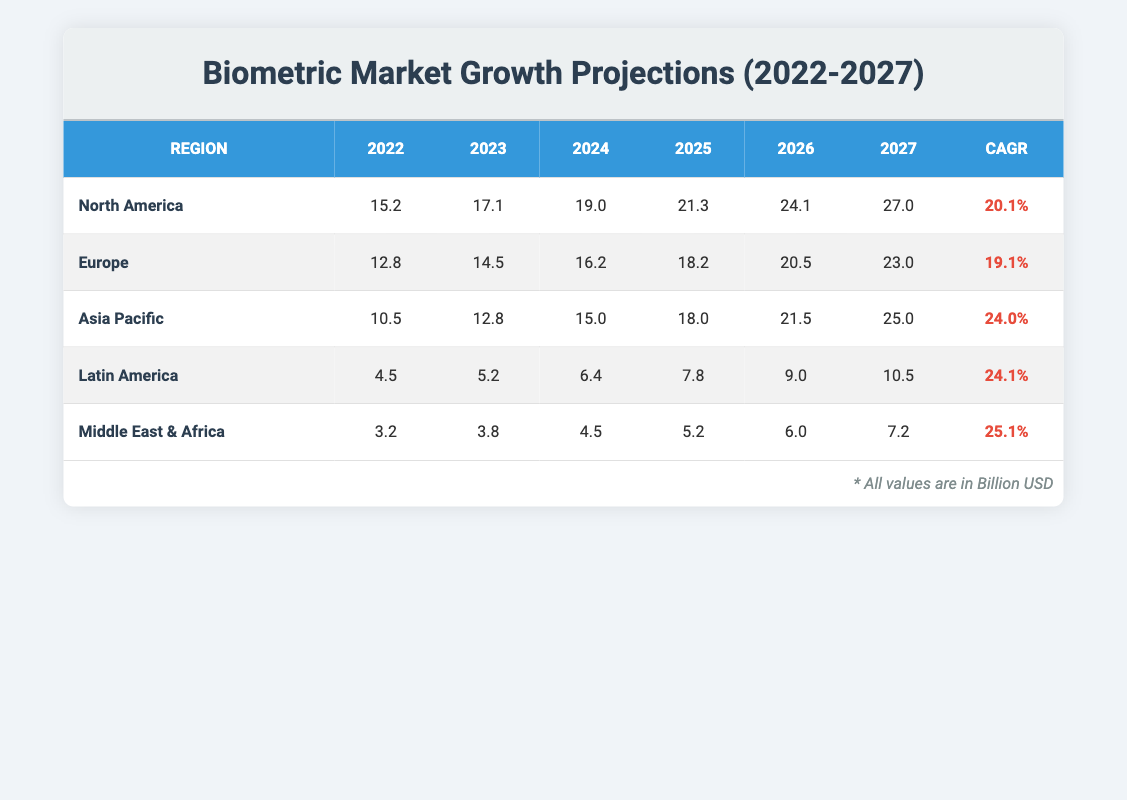What was the projected market value of biometric technologies in North America in 2025? According to the table, the projected market value of biometric technologies in North America for 2025 is directly listed as 21.3 billion USD.
Answer: 21.3 billion USD Which region has the highest projected market value in 2027? The table shows projected values for 2027, with North America at 27.0, Europe at 23.0, Asia Pacific at 25.0, Latin America at 10.5, and Middle East & Africa at 7.2. North America has the highest value of 27.0 billion USD.
Answer: North America What is the compound annual growth rate (CAGR) for the Asia Pacific region? The table lists the CAGR for the Asia Pacific region as 24.0%.
Answer: 24.0% What is the total projected market value for Latin America from 2022 to 2027? The projected values for Latin America from 2022 to 2027 are 4.5, 5.2, 6.4, 7.8, 9.0, and 10.5 billion USD. Adding these values gives: 4.5 + 5.2 + 6.4 + 7.8 + 9.0 + 10.5 = 43.4 billion USD.
Answer: 43.4 billion USD Is the CAGR for Middle East & Africa greater than that for Europe? The table shows that the CAGR for Middle East & Africa is 25.1% and for Europe is 19.1%. Since 25.1% is greater than 19.1%, the statement is true.
Answer: Yes What was the increase in projected market value for North America from 2022 to 2026? The projected market values for North America are 15.2 (2022) and 24.1 (2026). The increase is calculated as 24.1 - 15.2 = 8.9 billion USD.
Answer: 8.9 billion USD How does the CAGR of Latin America compare to that of Asia Pacific? The CAGR for Latin America is 24.1%, and for Asia Pacific, it is 24.0%. Since 24.1% is greater than 24.0%, Latin America's CAGR is higher.
Answer: Latin America has a higher CAGR Which region has a projected market value of 3.2 billion USD in 2022? The table lists the projected market value of 3.2 billion USD in 2022 for the Middle East & Africa region.
Answer: Middle East & Africa What is the average market value of biometric technologies in Europe from 2023 to 2027? The projected values in Europe from 2023 to 2027 are 14.5, 16.2, 18.2, 20.5, and 23.0 billion USD. To find the average, sum these values (14.5 + 16.2 + 18.2 + 20.5 + 23.0) = 92.4 billion USD, and divide by 5, giving an average of 18.48 billion USD.
Answer: 18.48 billion USD 